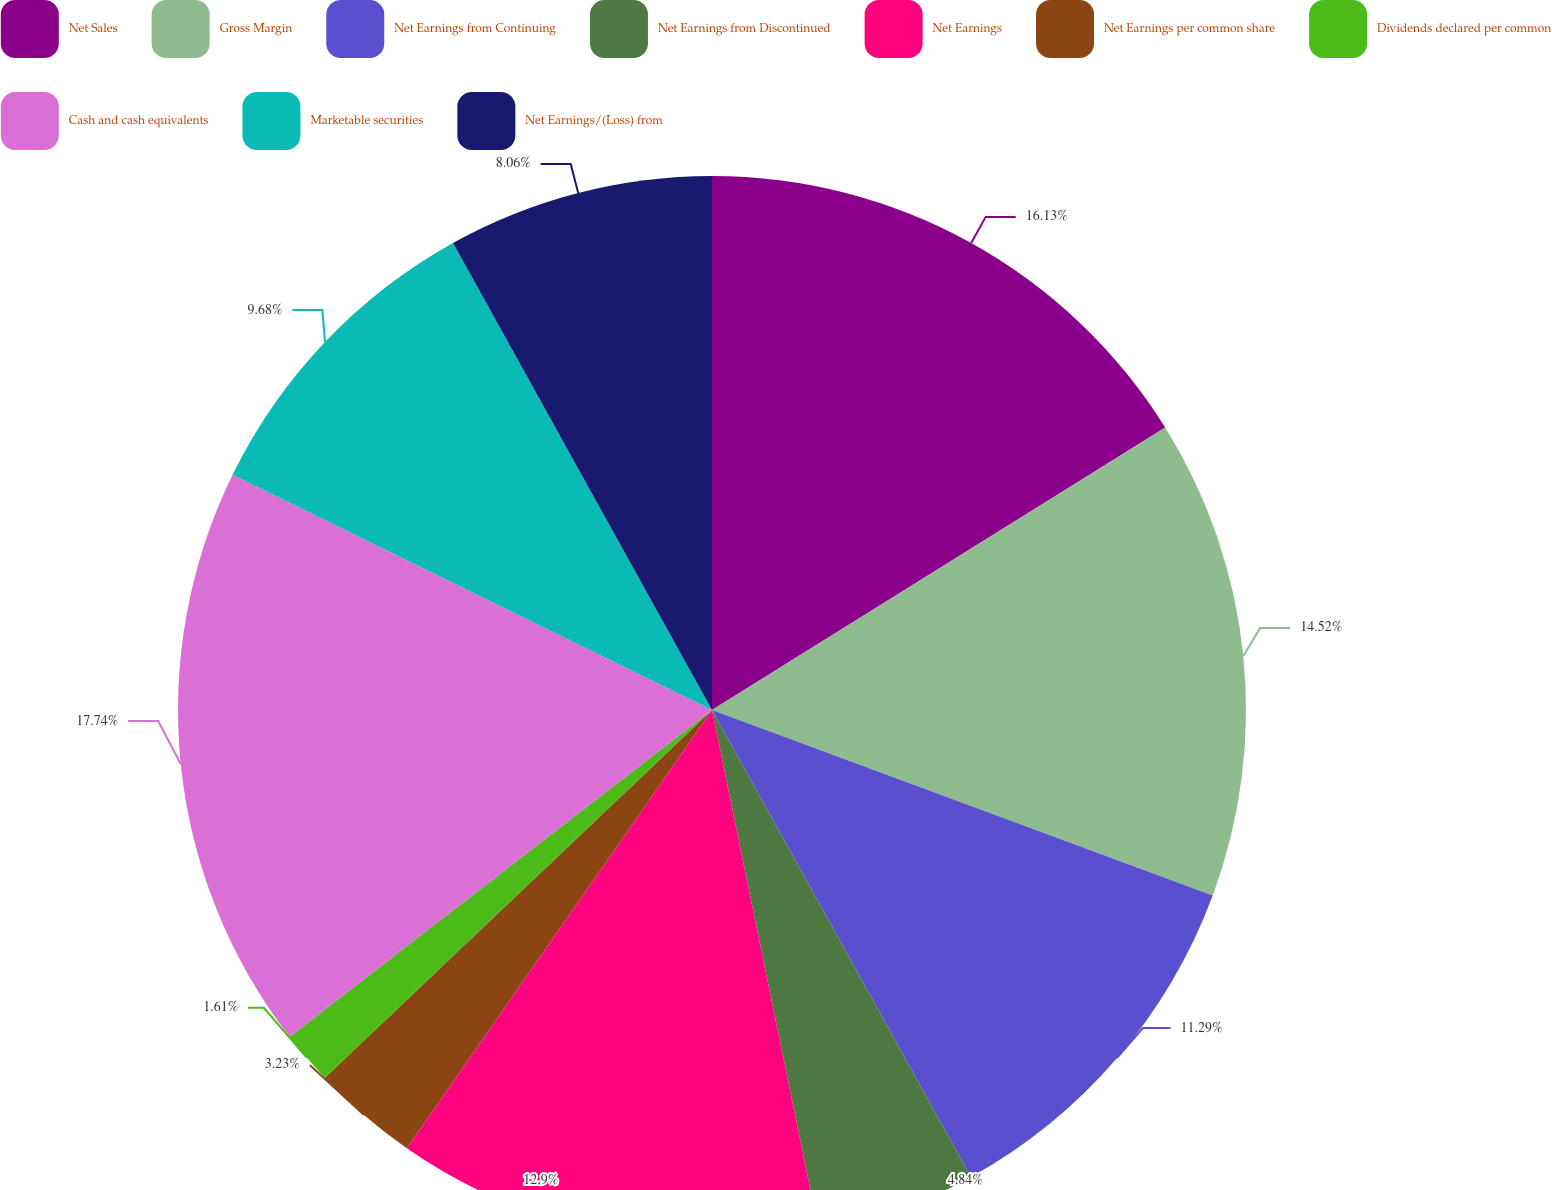Convert chart. <chart><loc_0><loc_0><loc_500><loc_500><pie_chart><fcel>Net Sales<fcel>Gross Margin<fcel>Net Earnings from Continuing<fcel>Net Earnings from Discontinued<fcel>Net Earnings<fcel>Net Earnings per common share<fcel>Dividends declared per common<fcel>Cash and cash equivalents<fcel>Marketable securities<fcel>Net Earnings/(Loss) from<nl><fcel>16.13%<fcel>14.52%<fcel>11.29%<fcel>4.84%<fcel>12.9%<fcel>3.23%<fcel>1.61%<fcel>17.74%<fcel>9.68%<fcel>8.06%<nl></chart> 